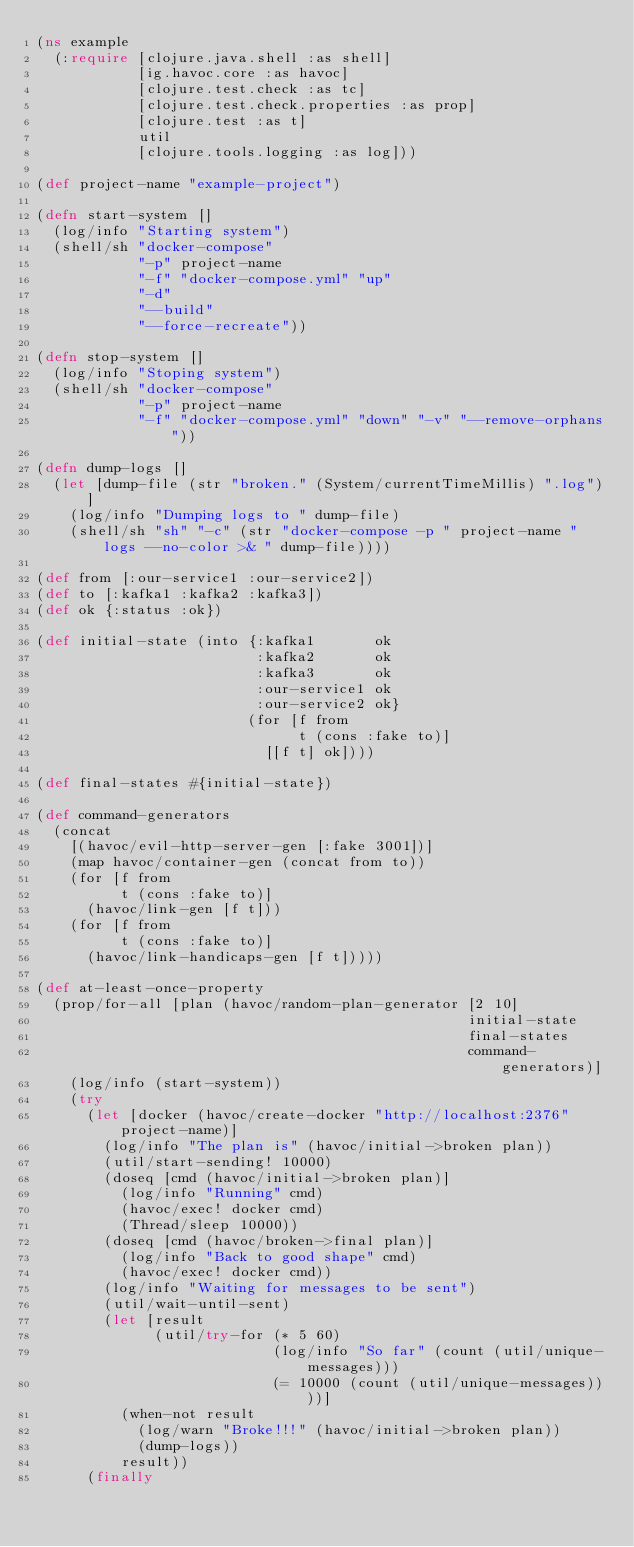<code> <loc_0><loc_0><loc_500><loc_500><_Clojure_>(ns example
  (:require [clojure.java.shell :as shell]
            [ig.havoc.core :as havoc]
            [clojure.test.check :as tc]
            [clojure.test.check.properties :as prop]
            [clojure.test :as t]
            util
            [clojure.tools.logging :as log]))

(def project-name "example-project")

(defn start-system []
  (log/info "Starting system")
  (shell/sh "docker-compose"
            "-p" project-name
            "-f" "docker-compose.yml" "up"
            "-d"
            "--build"
            "--force-recreate"))

(defn stop-system []
  (log/info "Stoping system")
  (shell/sh "docker-compose"
            "-p" project-name
            "-f" "docker-compose.yml" "down" "-v" "--remove-orphans"))

(defn dump-logs []
  (let [dump-file (str "broken." (System/currentTimeMillis) ".log")]
    (log/info "Dumping logs to " dump-file)
    (shell/sh "sh" "-c" (str "docker-compose -p " project-name " logs --no-color >& " dump-file))))

(def from [:our-service1 :our-service2])
(def to [:kafka1 :kafka2 :kafka3])
(def ok {:status :ok})

(def initial-state (into {:kafka1       ok
                          :kafka2       ok
                          :kafka3       ok
                          :our-service1 ok
                          :our-service2 ok}
                         (for [f from
                               t (cons :fake to)]
                           [[f t] ok])))

(def final-states #{initial-state})

(def command-generators
  (concat
    [(havoc/evil-http-server-gen [:fake 3001])]
    (map havoc/container-gen (concat from to))
    (for [f from
          t (cons :fake to)]
      (havoc/link-gen [f t]))
    (for [f from
          t (cons :fake to)]
      (havoc/link-handicaps-gen [f t]))))

(def at-least-once-property
  (prop/for-all [plan (havoc/random-plan-generator [2 10]
                                                   initial-state
                                                   final-states
                                                   command-generators)]
    (log/info (start-system))
    (try
      (let [docker (havoc/create-docker "http://localhost:2376" project-name)]
        (log/info "The plan is" (havoc/initial->broken plan))
        (util/start-sending! 10000)
        (doseq [cmd (havoc/initial->broken plan)]
          (log/info "Running" cmd)
          (havoc/exec! docker cmd)
          (Thread/sleep 10000))
        (doseq [cmd (havoc/broken->final plan)]
          (log/info "Back to good shape" cmd)
          (havoc/exec! docker cmd))
        (log/info "Waiting for messages to be sent")
        (util/wait-until-sent)
        (let [result
              (util/try-for (* 5 60)
                            (log/info "So far" (count (util/unique-messages)))
                            (= 10000 (count (util/unique-messages))))]
          (when-not result
            (log/warn "Broke!!!" (havoc/initial->broken plan))
            (dump-logs))
          result))
      (finally</code> 